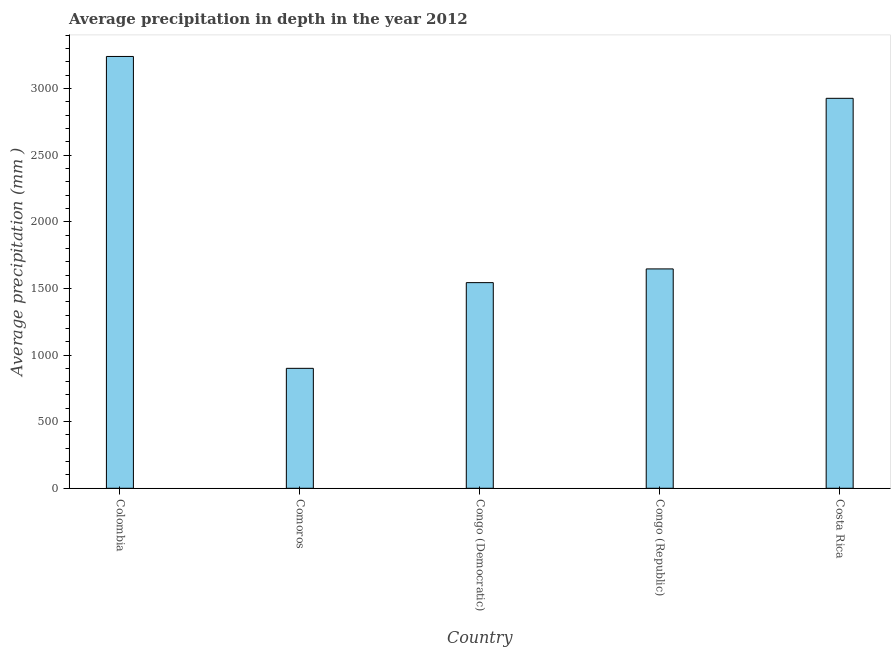What is the title of the graph?
Provide a succinct answer. Average precipitation in depth in the year 2012. What is the label or title of the Y-axis?
Provide a short and direct response. Average precipitation (mm ). What is the average precipitation in depth in Congo (Republic)?
Keep it short and to the point. 1646. Across all countries, what is the maximum average precipitation in depth?
Your answer should be very brief. 3240. Across all countries, what is the minimum average precipitation in depth?
Provide a succinct answer. 900. In which country was the average precipitation in depth maximum?
Your answer should be compact. Colombia. In which country was the average precipitation in depth minimum?
Your answer should be very brief. Comoros. What is the sum of the average precipitation in depth?
Your response must be concise. 1.03e+04. What is the difference between the average precipitation in depth in Congo (Democratic) and Costa Rica?
Ensure brevity in your answer.  -1383. What is the average average precipitation in depth per country?
Provide a short and direct response. 2051. What is the median average precipitation in depth?
Provide a short and direct response. 1646. In how many countries, is the average precipitation in depth greater than 1500 mm?
Offer a very short reply. 4. What is the ratio of the average precipitation in depth in Congo (Democratic) to that in Costa Rica?
Ensure brevity in your answer.  0.53. Is the average precipitation in depth in Colombia less than that in Congo (Democratic)?
Offer a terse response. No. Is the difference between the average precipitation in depth in Congo (Democratic) and Costa Rica greater than the difference between any two countries?
Your answer should be very brief. No. What is the difference between the highest and the second highest average precipitation in depth?
Ensure brevity in your answer.  314. Is the sum of the average precipitation in depth in Comoros and Costa Rica greater than the maximum average precipitation in depth across all countries?
Offer a very short reply. Yes. What is the difference between the highest and the lowest average precipitation in depth?
Make the answer very short. 2340. In how many countries, is the average precipitation in depth greater than the average average precipitation in depth taken over all countries?
Provide a short and direct response. 2. How many bars are there?
Your answer should be very brief. 5. Are all the bars in the graph horizontal?
Offer a terse response. No. How many countries are there in the graph?
Offer a terse response. 5. What is the Average precipitation (mm ) in Colombia?
Your answer should be compact. 3240. What is the Average precipitation (mm ) of Comoros?
Your response must be concise. 900. What is the Average precipitation (mm ) in Congo (Democratic)?
Make the answer very short. 1543. What is the Average precipitation (mm ) of Congo (Republic)?
Make the answer very short. 1646. What is the Average precipitation (mm ) of Costa Rica?
Keep it short and to the point. 2926. What is the difference between the Average precipitation (mm ) in Colombia and Comoros?
Your answer should be compact. 2340. What is the difference between the Average precipitation (mm ) in Colombia and Congo (Democratic)?
Your response must be concise. 1697. What is the difference between the Average precipitation (mm ) in Colombia and Congo (Republic)?
Your answer should be very brief. 1594. What is the difference between the Average precipitation (mm ) in Colombia and Costa Rica?
Keep it short and to the point. 314. What is the difference between the Average precipitation (mm ) in Comoros and Congo (Democratic)?
Your answer should be very brief. -643. What is the difference between the Average precipitation (mm ) in Comoros and Congo (Republic)?
Keep it short and to the point. -746. What is the difference between the Average precipitation (mm ) in Comoros and Costa Rica?
Offer a very short reply. -2026. What is the difference between the Average precipitation (mm ) in Congo (Democratic) and Congo (Republic)?
Provide a succinct answer. -103. What is the difference between the Average precipitation (mm ) in Congo (Democratic) and Costa Rica?
Provide a succinct answer. -1383. What is the difference between the Average precipitation (mm ) in Congo (Republic) and Costa Rica?
Make the answer very short. -1280. What is the ratio of the Average precipitation (mm ) in Colombia to that in Comoros?
Provide a succinct answer. 3.6. What is the ratio of the Average precipitation (mm ) in Colombia to that in Congo (Democratic)?
Your answer should be very brief. 2.1. What is the ratio of the Average precipitation (mm ) in Colombia to that in Congo (Republic)?
Offer a terse response. 1.97. What is the ratio of the Average precipitation (mm ) in Colombia to that in Costa Rica?
Make the answer very short. 1.11. What is the ratio of the Average precipitation (mm ) in Comoros to that in Congo (Democratic)?
Give a very brief answer. 0.58. What is the ratio of the Average precipitation (mm ) in Comoros to that in Congo (Republic)?
Your answer should be very brief. 0.55. What is the ratio of the Average precipitation (mm ) in Comoros to that in Costa Rica?
Offer a very short reply. 0.31. What is the ratio of the Average precipitation (mm ) in Congo (Democratic) to that in Congo (Republic)?
Provide a succinct answer. 0.94. What is the ratio of the Average precipitation (mm ) in Congo (Democratic) to that in Costa Rica?
Keep it short and to the point. 0.53. What is the ratio of the Average precipitation (mm ) in Congo (Republic) to that in Costa Rica?
Make the answer very short. 0.56. 